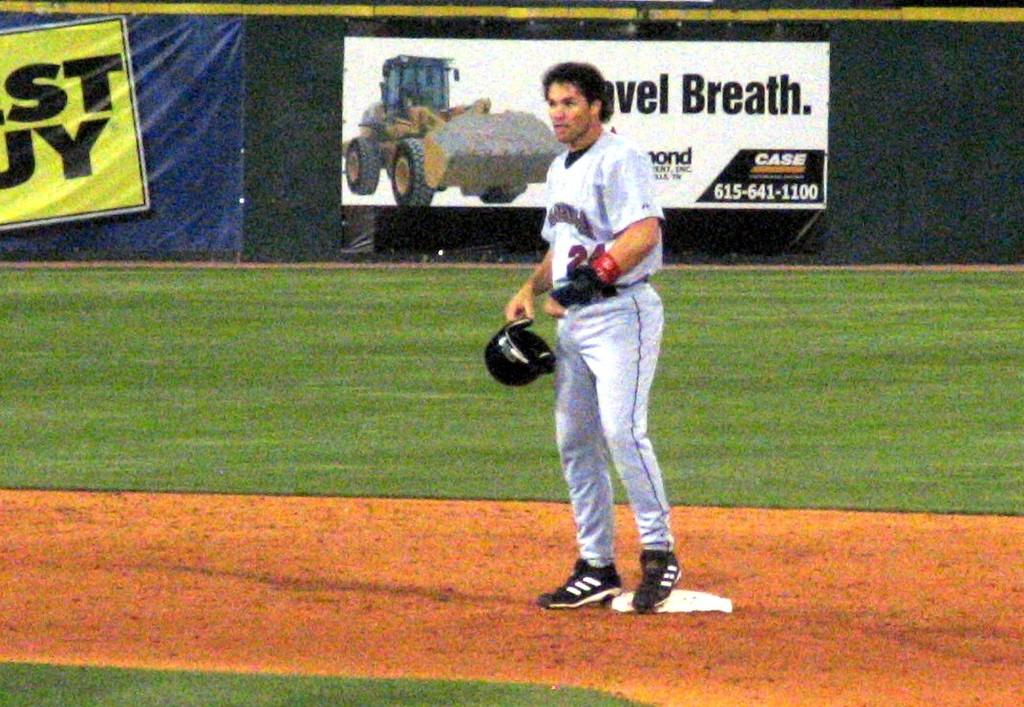Provide a one-sentence caption for the provided image. A baseball player is standing in front of a billboard for case tractors. 